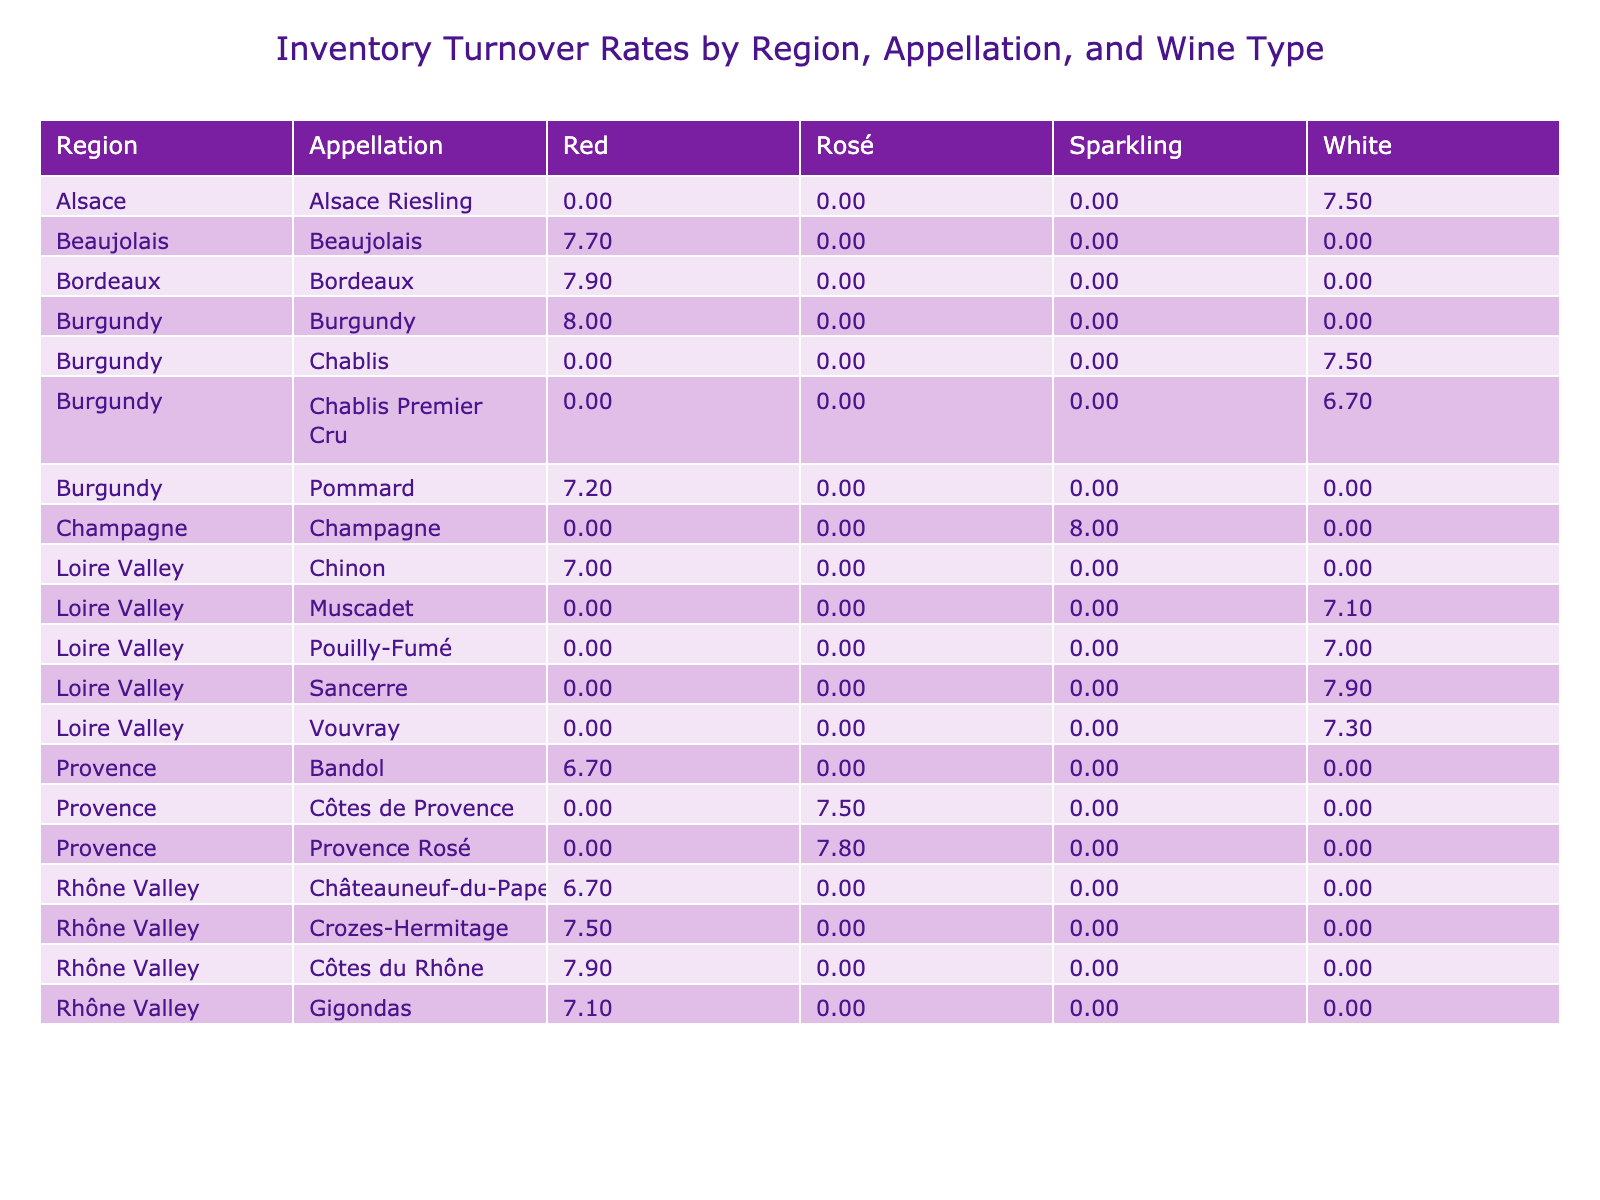What is the inventory turnover rate for Bordeaux? Looking at the table, in the Bordeaux region, the red wine has an inventory turnover rate of 7.9.
Answer: 7.9 Which appellation has the highest inventory turnover rate? The table shows that Champagne has the highest inventory turnover rate at 8.0.
Answer: Champagne What are the inventory turnover rates for white wines in the Loire Valley? In the Loire Valley, the white wines listed are Sancerre (7.9), Pouilly-Fumé (7.0), Muscadet (7.1), Chinon (7.0), and Vouvray (7.3). The highest is Sancerre at 7.9.
Answer: Sancerre 7.9 Is the inventory turnover rate for Muscadet higher than that of Châteauneuf-du-Pape? Muscadet has an inventory turnover rate of 7.1, while Châteauneuf-du-Pape is 6.7. Since 7.1 is greater than 6.7, the statement is true.
Answer: Yes What is the average inventory turnover rate for red wines across all regions? To find the average for red wines, we take the turnover rates: Bordeaux (7.9), Burgundy (8.0), Côtes du Rhône (7.9), Châteauneuf-du-Pape (6.7), Beaujolais (7.7), Bandol (6.7), and Gigondas (7.1). Adding these: 7.9 + 8.0 + 7.9 + 6.7 + 7.7 + 6.7 + 7.1 = 52.0. There are 7 data points, so the average is 52.0 / 7 = 7.43.
Answer: 7.43 Which wine type has the lowest inventory turnover rate in the Provence region? Analyzing the Provence region, the red wine (Bandol at 6.7) and rosé (Côtes de Provence at 7.5) are compared. Bandol has the lower turnover rate at 6.7.
Answer: Bandol (red) at 6.7 Is it true that all white wines have an inventory turnover rate of 7.5 or higher? Examining the white wines, Chablis (7.5), Sancerre (7.9), Pouilly-Fumé (7.0), Muscadet (7.1), and Vouvray (7.3) show some wines are below 7.5. Specifically, Pouilly-Fumé is 7.0 which is below 7.5, so the statement is false.
Answer: No Which region has a rosé wine with an inventory turnover rate of 7.8? The Provence region has a rosé, specifically Provence Rosé, with an inventory turnover rate of 7.8. Looking at the table confirms this detail.
Answer: Provence What is the difference in inventory turnover rates between the best and worst appraisals of red wines? The highest inventory turnover rate for red wines is from Burgundy (8.0 for Burgundy red) and the lowest is Bandol (6.7). The difference is calculated by subtracting: 8.0 - 6.7 = 1.3.
Answer: 1.3 